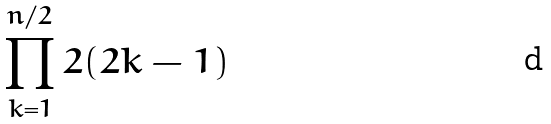Convert formula to latex. <formula><loc_0><loc_0><loc_500><loc_500>\prod _ { k = 1 } ^ { n / 2 } 2 ( 2 k - 1 )</formula> 